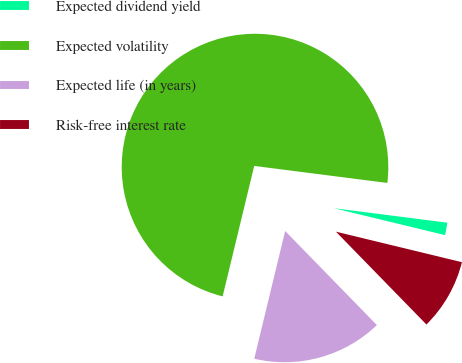Convert chart. <chart><loc_0><loc_0><loc_500><loc_500><pie_chart><fcel>Expected dividend yield<fcel>Expected volatility<fcel>Expected life (in years)<fcel>Risk-free interest rate<nl><fcel>1.76%<fcel>73.25%<fcel>16.08%<fcel>8.92%<nl></chart> 